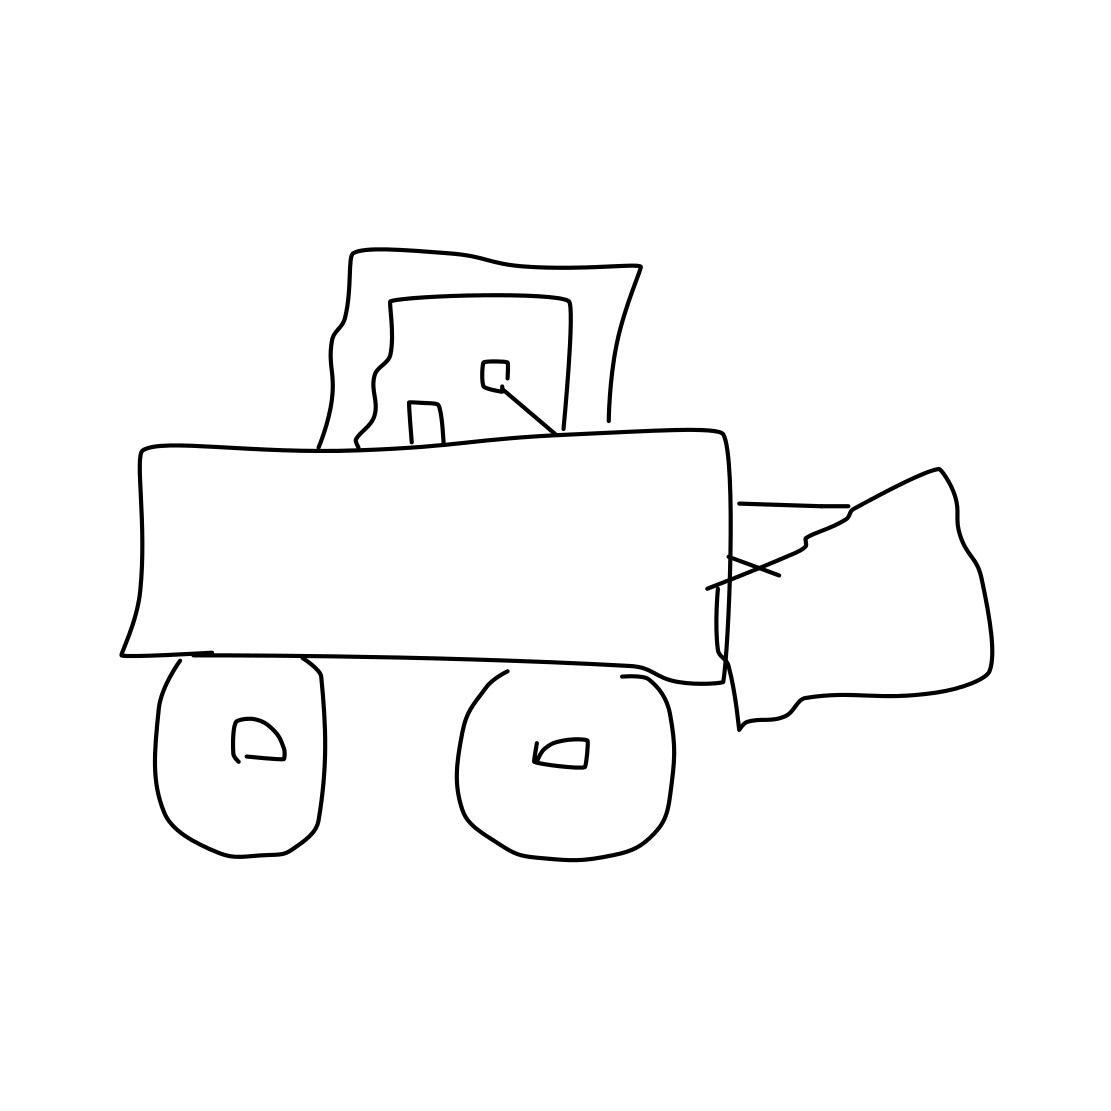Is this a nose in the image? No, the image does not show a nose or any human features. It is actually a line drawing of a bulldozer. There are no elements in the image that resemble a nose. 